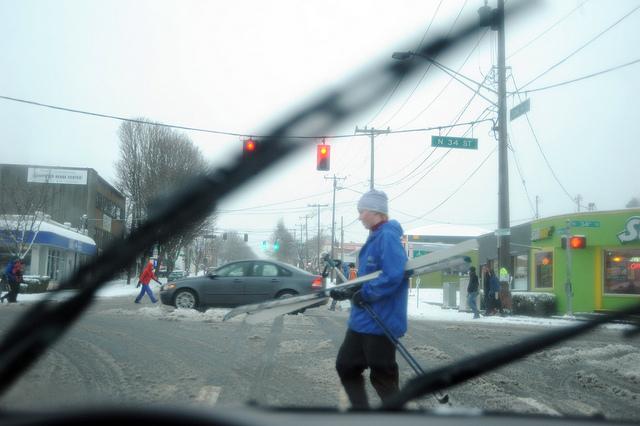Is it near the end or beginning of winter?
Answer briefly. End. What is on the windshield?
Quick response, please. Windshield wipers. What color is the crossing the street?
Give a very brief answer. Blue. 